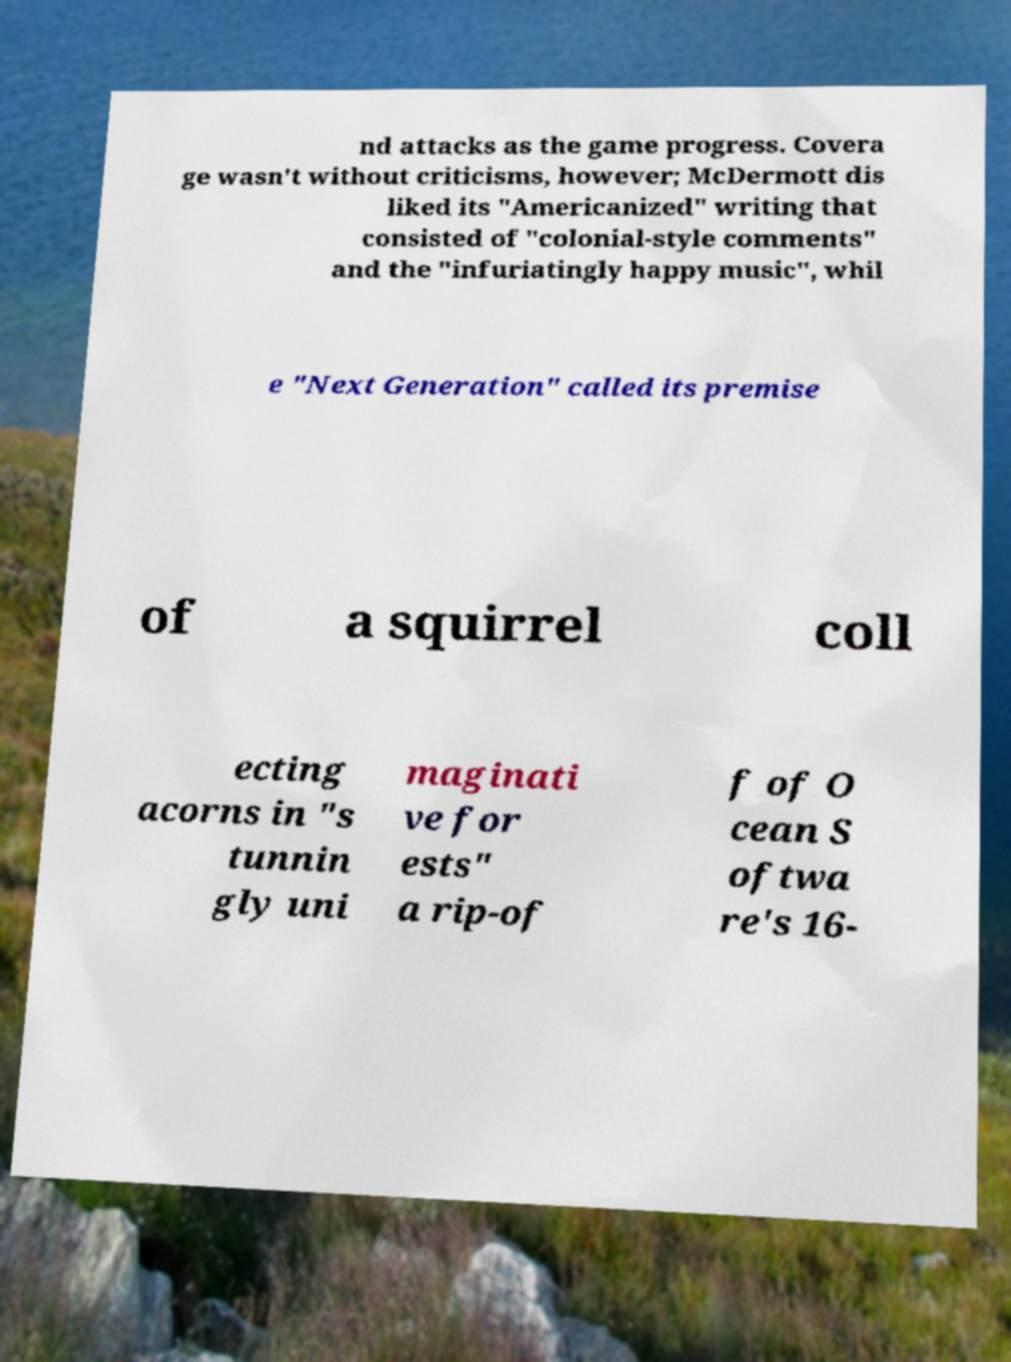Can you read and provide the text displayed in the image?This photo seems to have some interesting text. Can you extract and type it out for me? nd attacks as the game progress. Covera ge wasn't without criticisms, however; McDermott dis liked its "Americanized" writing that consisted of "colonial-style comments" and the "infuriatingly happy music", whil e "Next Generation" called its premise of a squirrel coll ecting acorns in "s tunnin gly uni maginati ve for ests" a rip-of f of O cean S oftwa re's 16- 